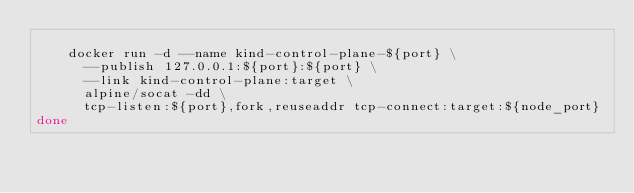Convert code to text. <code><loc_0><loc_0><loc_500><loc_500><_Bash_>
    docker run -d --name kind-control-plane-${port} \
      --publish 127.0.0.1:${port}:${port} \
      --link kind-control-plane:target \
      alpine/socat -dd \
      tcp-listen:${port},fork,reuseaddr tcp-connect:target:${node_port}
done</code> 